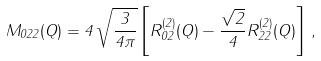<formula> <loc_0><loc_0><loc_500><loc_500>M _ { 0 2 2 } ( Q ) = 4 \, \sqrt { \frac { 3 } { 4 \pi } } \left [ R _ { 0 2 } ^ { ( 2 ) } ( Q ) - \frac { \sqrt { 2 } } { 4 } R _ { 2 2 } ^ { ( 2 ) } ( Q ) \right ] \, ,</formula> 